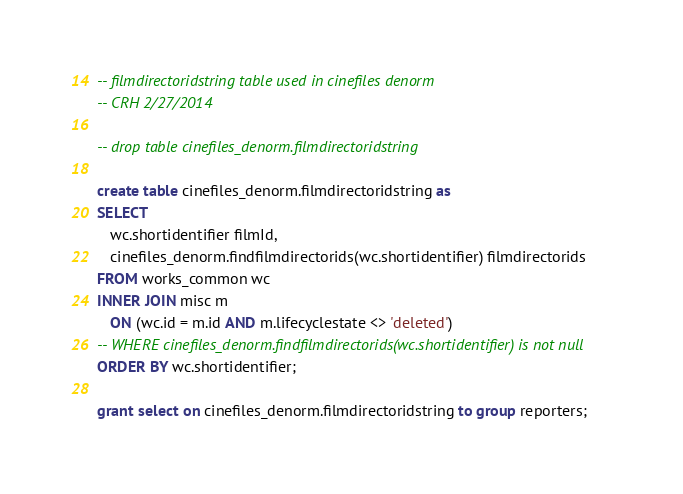<code> <loc_0><loc_0><loc_500><loc_500><_SQL_>-- filmdirectoridstring table used in cinefiles denorm
-- CRH 2/27/2014

-- drop table cinefiles_denorm.filmdirectoridstring

create table cinefiles_denorm.filmdirectoridstring as
SELECT
   wc.shortidentifier filmId, 
   cinefiles_denorm.findfilmdirectorids(wc.shortidentifier) filmdirectorids
FROM works_common wc
INNER JOIN misc m
   ON (wc.id = m.id AND m.lifecyclestate <> 'deleted')
-- WHERE cinefiles_denorm.findfilmdirectorids(wc.shortidentifier) is not null
ORDER BY wc.shortidentifier;

grant select on cinefiles_denorm.filmdirectoridstring to group reporters;</code> 